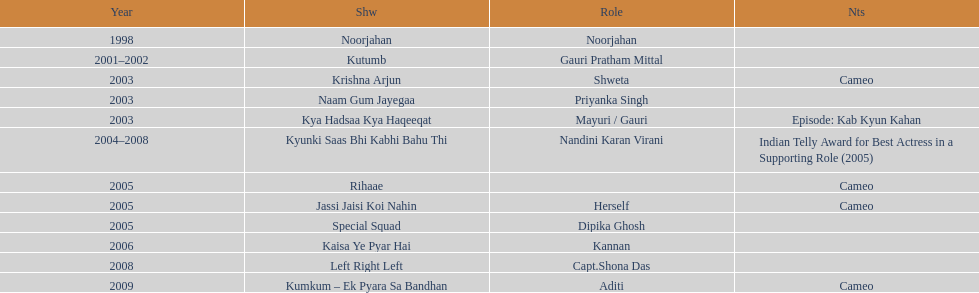How many different tv shows was gauri tejwani in before 2000? 1. 